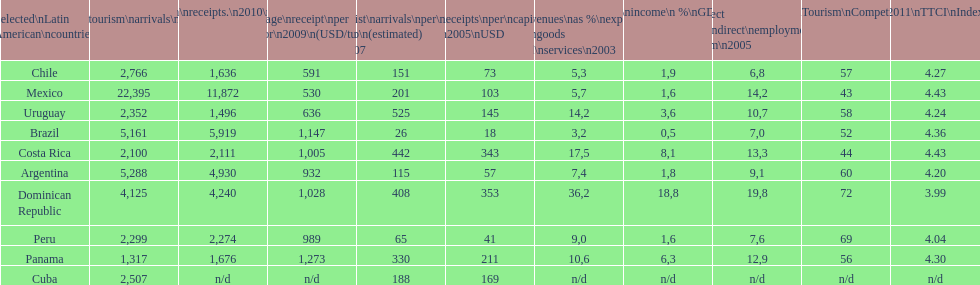Which country experienced the smallest number of arrivals per 1,000 people in the year 2007 (estimated)? Brazil. 